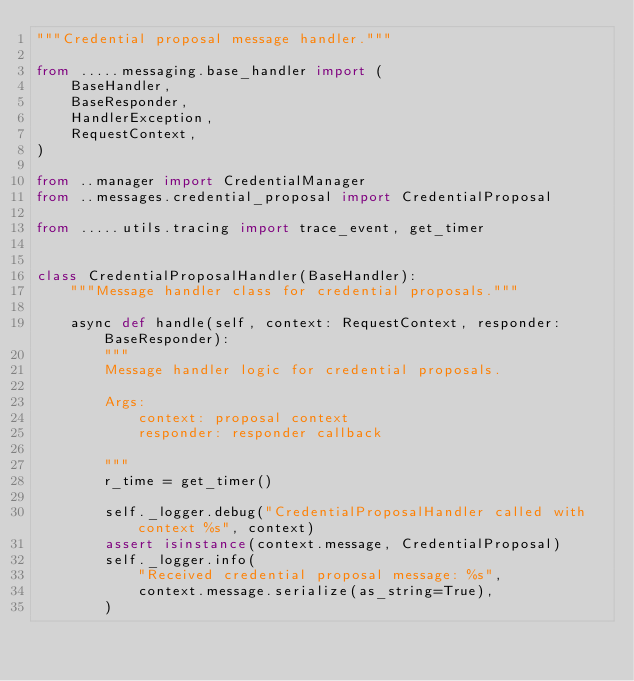<code> <loc_0><loc_0><loc_500><loc_500><_Python_>"""Credential proposal message handler."""

from .....messaging.base_handler import (
    BaseHandler,
    BaseResponder,
    HandlerException,
    RequestContext,
)

from ..manager import CredentialManager
from ..messages.credential_proposal import CredentialProposal

from .....utils.tracing import trace_event, get_timer


class CredentialProposalHandler(BaseHandler):
    """Message handler class for credential proposals."""

    async def handle(self, context: RequestContext, responder: BaseResponder):
        """
        Message handler logic for credential proposals.

        Args:
            context: proposal context
            responder: responder callback

        """
        r_time = get_timer()

        self._logger.debug("CredentialProposalHandler called with context %s", context)
        assert isinstance(context.message, CredentialProposal)
        self._logger.info(
            "Received credential proposal message: %s",
            context.message.serialize(as_string=True),
        )
</code> 